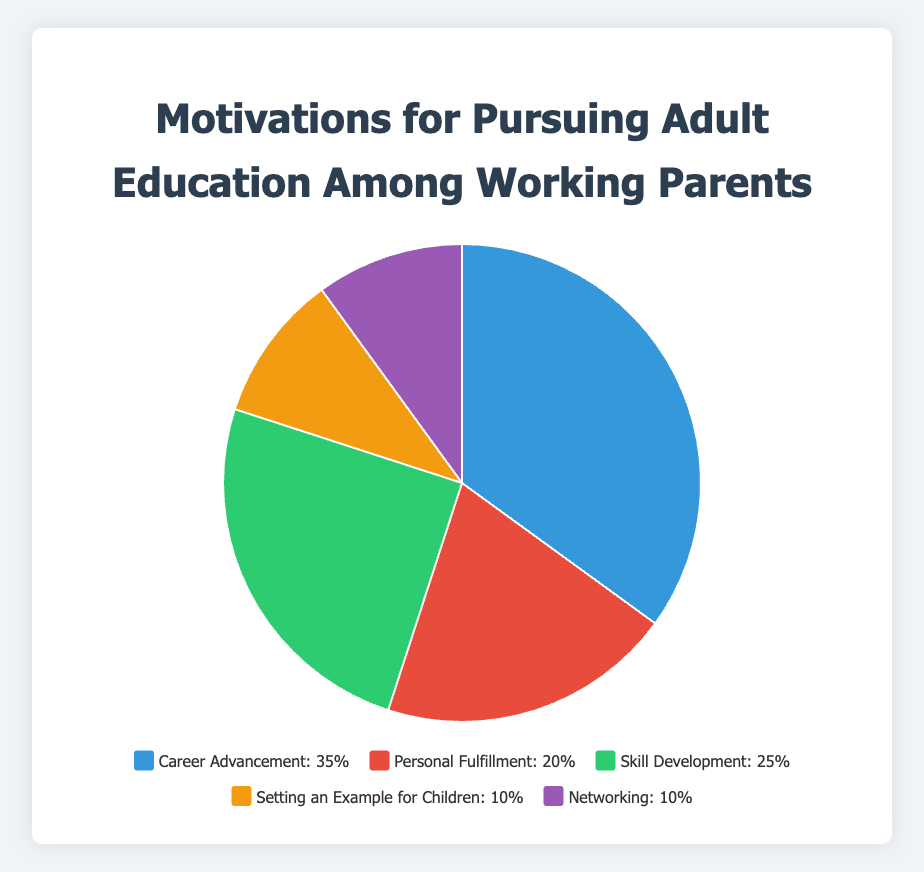Which motivation has the highest percentage among working parents? The pie chart shows that "Career Advancement" has the largest slice, indicating it has the highest percentage among the given motivations.
Answer: Career Advancement Which two motivations are equally prioritized? Looking at the pie chart, both "Setting an Example for Children" and "Networking" have similarly sized slices, indicating they each represent 10%.
Answer: Setting an Example for Children and Networking What is the combined percentage of Career Advancement and Skill Development? Career Advancement is 35% and Skill Development is 25%. Adding these two percentages together gives 35% + 25% = 60%.
Answer: 60% Is the percentage of Personal Fulfillment greater than Setting an Example for Children? Yes, comparing the sizes of the slices, Personal Fulfillment is labeled as 20% whereas Setting an Example for Children is labeled as 10%.
Answer: Yes How much larger is Career Advancement compared to Networking? Career Advancement is 35% and Networking is 10%. The difference is 35% - 10% = 25%.
Answer: 25% What is the total percentage represented by motivations other than Career Advancement? Summing up the percentages for Personal Fulfillment, Skill Development, Setting an Example for Children, and Networking gives 20% + 25% + 10% + 10% = 65%.
Answer: 65% Which motivation is represented by the green color? By referring to the colors in the chart, the green color corresponds to "Skill Development."
Answer: Skill Development What percentage of working parents pursue education for Setting an Example for Children? The slice labeled "Setting an Example for Children" represents 10% on the pie chart.
Answer: 10% If the Personal Fulfillment percentage were to double, what would it be? The current percentage for Personal Fulfillment is 20%. Doubling this would result in 20% * 2 = 40%.
Answer: 40% Rank the motivations from highest to lowest percentage. From the pie chart, the order from highest to lowest is: Career Advancement (35%), Skill Development (25%), Personal Fulfillment (20%), Setting an Example for Children (10%), Networking (10%).
Answer: Career Advancement, Skill Development, Personal Fulfillment, Setting an Example for Children, Networking 